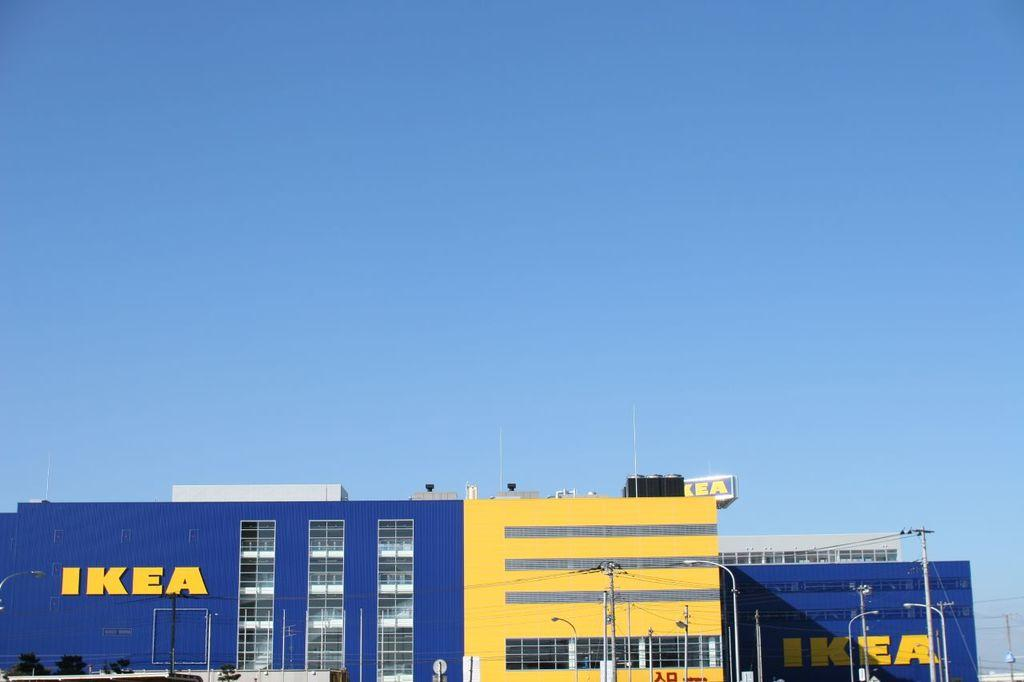What type of structure is in the image? There is a building in the image. What is located in front of the building? Trees, sign boards, current poles, and street lights are present in front of the building. What can be seen in the background of the image? The sky is visible in the background of the image. What type of collar is visible on the building in the image? There is no collar present on the building in the image. What property does the building in the image possess that allows it to perform magic? There is no mention of magic or any magical properties associated with the building in the image. 